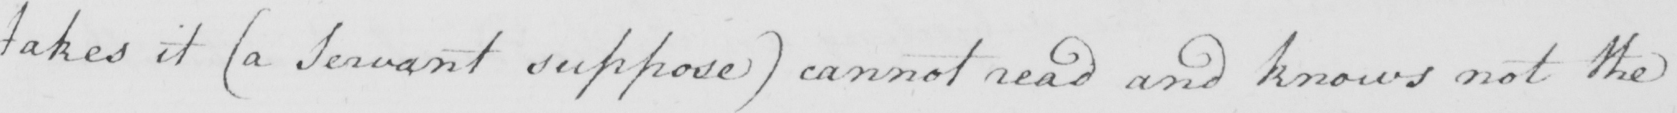What text is written in this handwritten line? takes it  ( a Servant suppose )  cannot read and knows not the 